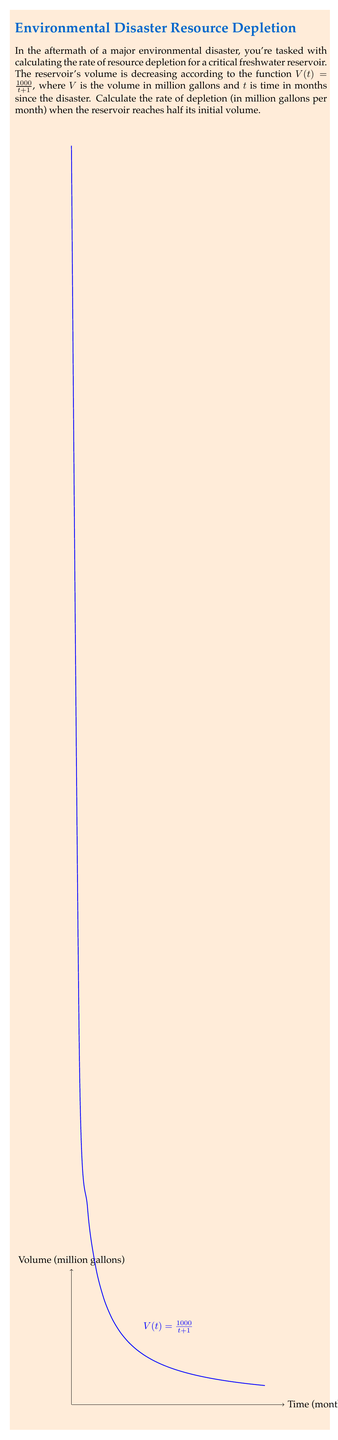Solve this math problem. Let's approach this step-by-step:

1) The initial volume (at t = 0) is:
   $$V(0) = \frac{1000}{0+1} = 1000$$ million gallons

2) We need to find when the volume is half of this, i.e., 500 million gallons:
   $$\frac{1000}{t+1} = 500$$

3) Solve for t:
   $$t+1 = \frac{1000}{500} = 2$$
   $$t = 1$$ month

4) The rate of depletion is the negative of the derivative of V(t):
   $$\frac{dV}{dt} = -\frac{1000}{(t+1)^2}$$

5) At t = 1 month (when the volume is half), the rate is:
   $$\text{Rate} = -\frac{1000}{(1+1)^2} = -\frac{1000}{4} = -250$$ million gallons per month

The negative sign indicates depletion (volume decreasing).
Answer: $-250$ million gallons per month 